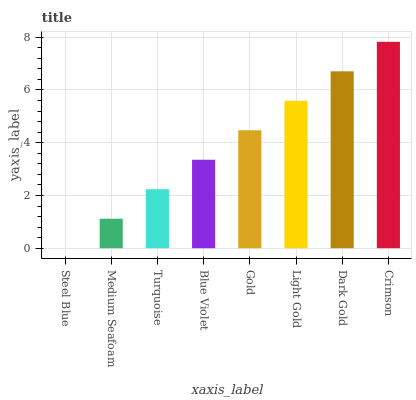Is Steel Blue the minimum?
Answer yes or no. Yes. Is Crimson the maximum?
Answer yes or no. Yes. Is Medium Seafoam the minimum?
Answer yes or no. No. Is Medium Seafoam the maximum?
Answer yes or no. No. Is Medium Seafoam greater than Steel Blue?
Answer yes or no. Yes. Is Steel Blue less than Medium Seafoam?
Answer yes or no. Yes. Is Steel Blue greater than Medium Seafoam?
Answer yes or no. No. Is Medium Seafoam less than Steel Blue?
Answer yes or no. No. Is Gold the high median?
Answer yes or no. Yes. Is Blue Violet the low median?
Answer yes or no. Yes. Is Crimson the high median?
Answer yes or no. No. Is Crimson the low median?
Answer yes or no. No. 